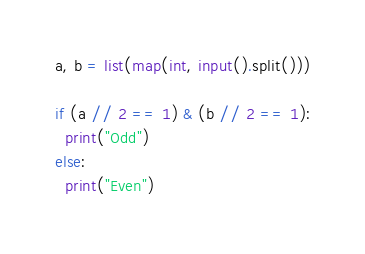Convert code to text. <code><loc_0><loc_0><loc_500><loc_500><_Python_>a, b = list(map(int, input().split()))

if (a // 2 == 1) & (b // 2 == 1):
  print("Odd")
else:
  print("Even")
</code> 